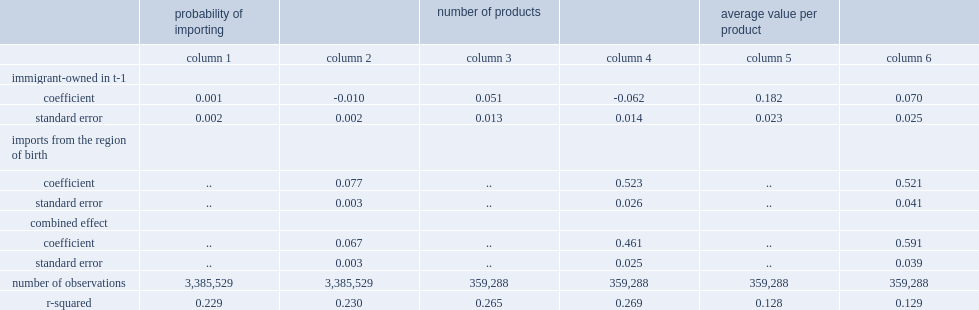Which firms are less likely to import from regions that are not the owner's region of origin,immigrant-owned or canadian-owned firms? Immigrant-owned in t-1. 